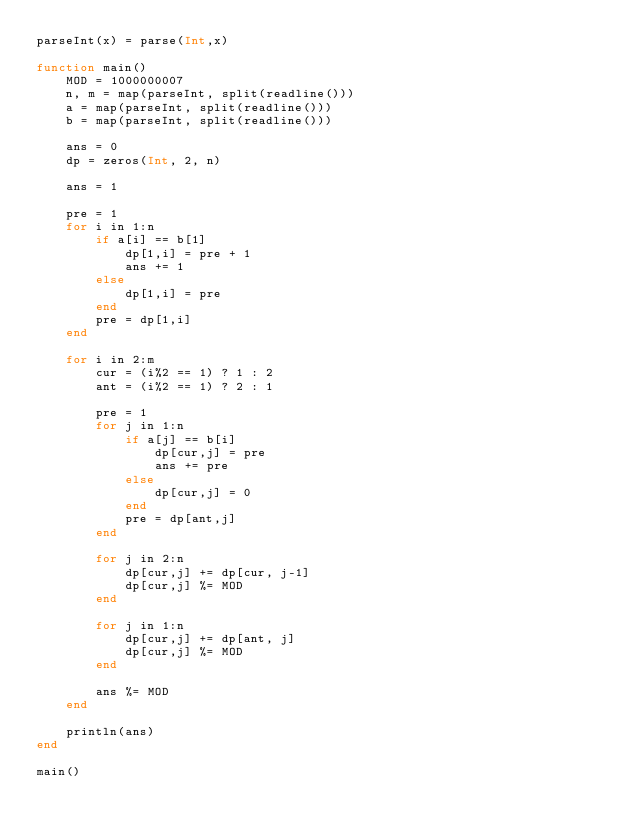Convert code to text. <code><loc_0><loc_0><loc_500><loc_500><_Julia_>parseInt(x) = parse(Int,x)

function main()
    MOD = 1000000007
    n, m = map(parseInt, split(readline()))
    a = map(parseInt, split(readline()))
    b = map(parseInt, split(readline()))

    ans = 0
    dp = zeros(Int, 2, n)

    ans = 1

    pre = 1
    for i in 1:n
        if a[i] == b[1]
            dp[1,i] = pre + 1
            ans += 1
        else 
            dp[1,i] = pre
        end
        pre = dp[1,i]
    end

    for i in 2:m
        cur = (i%2 == 1) ? 1 : 2
        ant = (i%2 == 1) ? 2 : 1

        pre = 1
        for j in 1:n
            if a[j] == b[i]
                dp[cur,j] = pre
                ans += pre
            else
                dp[cur,j] = 0
            end
            pre = dp[ant,j]
        end

        for j in 2:n
            dp[cur,j] += dp[cur, j-1]
            dp[cur,j] %= MOD
        end

        for j in 1:n
            dp[cur,j] += dp[ant, j]
            dp[cur,j] %= MOD
        end

        ans %= MOD
    end

    println(ans)
end

main()
</code> 